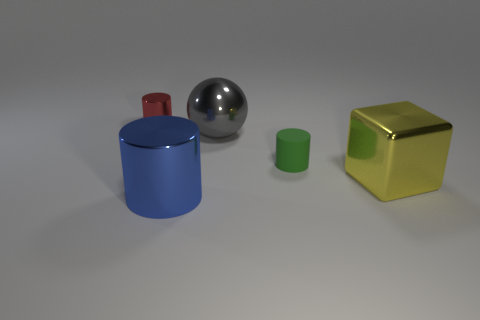Is there a small green cylinder made of the same material as the big yellow block?
Offer a very short reply. No. What is the shape of the green thing?
Give a very brief answer. Cylinder. There is a large thing on the right side of the small cylinder that is on the right side of the gray sphere; what is its shape?
Offer a very short reply. Cube. How many other things are there of the same shape as the yellow metallic thing?
Make the answer very short. 0. How big is the object that is behind the large object behind the tiny green cylinder?
Give a very brief answer. Small. Are there any red cylinders?
Provide a short and direct response. Yes. What number of yellow metal things are left of the metal cylinder behind the big cylinder?
Keep it short and to the point. 0. The metal object to the left of the blue metal thing has what shape?
Offer a terse response. Cylinder. What is the thing left of the metal cylinder that is in front of the shiny thing behind the gray sphere made of?
Provide a short and direct response. Metal. What number of other objects are the same size as the red metal thing?
Give a very brief answer. 1. 